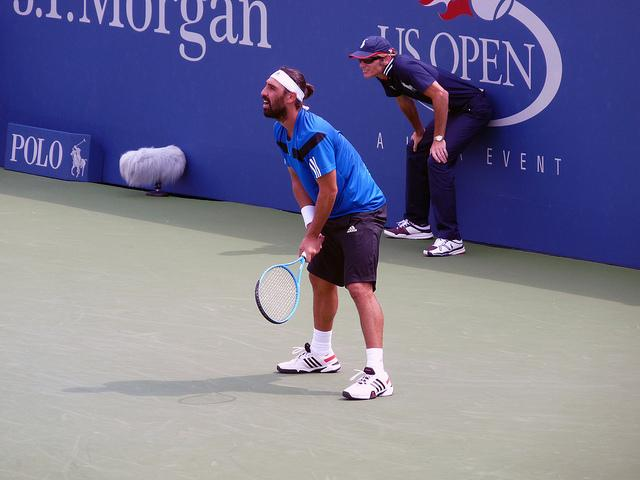What do the sunglasses worn here serve as?

Choices:
A) trauma protection
B) nothing
C) glare protection
D) fashion only glare protection 